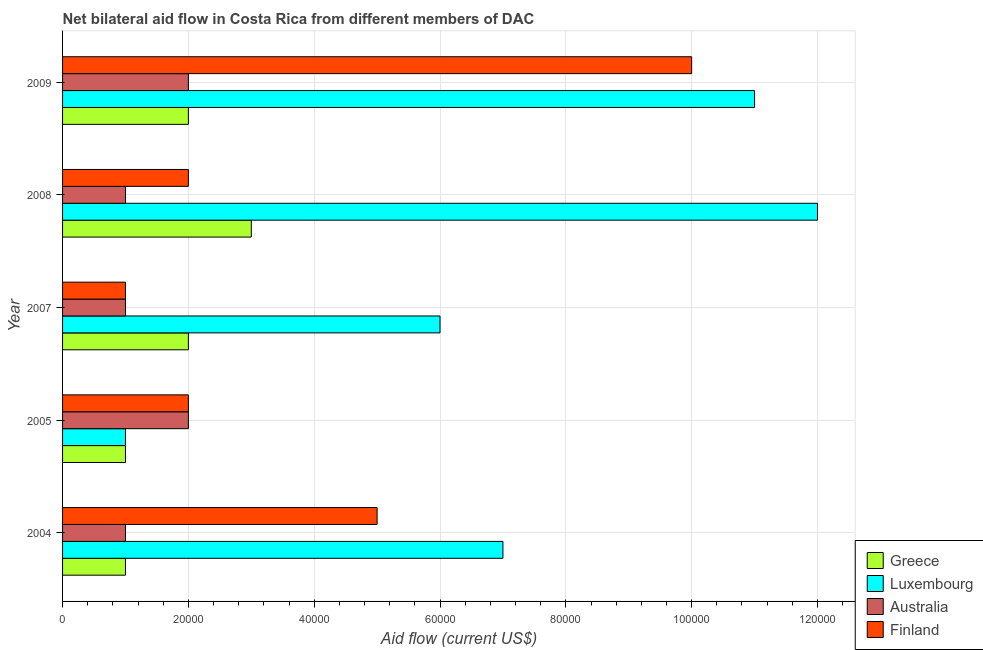How many groups of bars are there?
Your answer should be compact. 5. Are the number of bars per tick equal to the number of legend labels?
Offer a very short reply. Yes. Are the number of bars on each tick of the Y-axis equal?
Provide a short and direct response. Yes. How many bars are there on the 5th tick from the top?
Make the answer very short. 4. What is the label of the 4th group of bars from the top?
Keep it short and to the point. 2005. In how many cases, is the number of bars for a given year not equal to the number of legend labels?
Ensure brevity in your answer.  0. What is the amount of aid given by luxembourg in 2004?
Your answer should be very brief. 7.00e+04. Across all years, what is the maximum amount of aid given by greece?
Keep it short and to the point. 3.00e+04. Across all years, what is the minimum amount of aid given by australia?
Provide a short and direct response. 10000. In which year was the amount of aid given by australia minimum?
Offer a very short reply. 2004. What is the total amount of aid given by finland in the graph?
Your response must be concise. 2.00e+05. What is the difference between the amount of aid given by australia in 2004 and that in 2005?
Offer a very short reply. -10000. What is the average amount of aid given by luxembourg per year?
Give a very brief answer. 7.40e+04. In the year 2008, what is the difference between the amount of aid given by finland and amount of aid given by luxembourg?
Offer a very short reply. -1.00e+05. Is the difference between the amount of aid given by australia in 2004 and 2008 greater than the difference between the amount of aid given by luxembourg in 2004 and 2008?
Offer a terse response. Yes. What is the difference between the highest and the second highest amount of aid given by australia?
Ensure brevity in your answer.  0. What is the difference between the highest and the lowest amount of aid given by australia?
Make the answer very short. 10000. Is it the case that in every year, the sum of the amount of aid given by australia and amount of aid given by luxembourg is greater than the sum of amount of aid given by greece and amount of aid given by finland?
Provide a short and direct response. No. Is it the case that in every year, the sum of the amount of aid given by greece and amount of aid given by luxembourg is greater than the amount of aid given by australia?
Your response must be concise. No. How many bars are there?
Provide a short and direct response. 20. Are all the bars in the graph horizontal?
Your answer should be compact. Yes. How many years are there in the graph?
Ensure brevity in your answer.  5. What is the difference between two consecutive major ticks on the X-axis?
Make the answer very short. 2.00e+04. Where does the legend appear in the graph?
Offer a terse response. Bottom right. How are the legend labels stacked?
Ensure brevity in your answer.  Vertical. What is the title of the graph?
Provide a succinct answer. Net bilateral aid flow in Costa Rica from different members of DAC. Does "Social Insurance" appear as one of the legend labels in the graph?
Provide a short and direct response. No. What is the label or title of the X-axis?
Your answer should be compact. Aid flow (current US$). What is the label or title of the Y-axis?
Your answer should be very brief. Year. What is the Aid flow (current US$) of Luxembourg in 2004?
Your answer should be compact. 7.00e+04. What is the Aid flow (current US$) of Australia in 2004?
Offer a terse response. 10000. What is the Aid flow (current US$) of Luxembourg in 2007?
Offer a terse response. 6.00e+04. What is the Aid flow (current US$) of Australia in 2007?
Give a very brief answer. 10000. What is the Aid flow (current US$) in Greece in 2008?
Keep it short and to the point. 3.00e+04. What is the Aid flow (current US$) in Finland in 2008?
Give a very brief answer. 2.00e+04. What is the Aid flow (current US$) in Greece in 2009?
Your answer should be very brief. 2.00e+04. Across all years, what is the maximum Aid flow (current US$) in Greece?
Your answer should be compact. 3.00e+04. Across all years, what is the maximum Aid flow (current US$) of Finland?
Keep it short and to the point. 1.00e+05. Across all years, what is the minimum Aid flow (current US$) of Greece?
Keep it short and to the point. 10000. Across all years, what is the minimum Aid flow (current US$) in Luxembourg?
Make the answer very short. 10000. Across all years, what is the minimum Aid flow (current US$) in Australia?
Provide a short and direct response. 10000. Across all years, what is the minimum Aid flow (current US$) of Finland?
Provide a succinct answer. 10000. What is the total Aid flow (current US$) of Greece in the graph?
Provide a short and direct response. 9.00e+04. What is the total Aid flow (current US$) of Finland in the graph?
Keep it short and to the point. 2.00e+05. What is the difference between the Aid flow (current US$) in Greece in 2004 and that in 2005?
Offer a very short reply. 0. What is the difference between the Aid flow (current US$) of Australia in 2004 and that in 2005?
Keep it short and to the point. -10000. What is the difference between the Aid flow (current US$) in Luxembourg in 2004 and that in 2007?
Your answer should be compact. 10000. What is the difference between the Aid flow (current US$) of Finland in 2004 and that in 2007?
Provide a succinct answer. 4.00e+04. What is the difference between the Aid flow (current US$) of Luxembourg in 2004 and that in 2008?
Your answer should be very brief. -5.00e+04. What is the difference between the Aid flow (current US$) of Australia in 2004 and that in 2008?
Provide a short and direct response. 0. What is the difference between the Aid flow (current US$) in Greece in 2004 and that in 2009?
Ensure brevity in your answer.  -10000. What is the difference between the Aid flow (current US$) in Finland in 2004 and that in 2009?
Offer a terse response. -5.00e+04. What is the difference between the Aid flow (current US$) of Luxembourg in 2005 and that in 2007?
Your response must be concise. -5.00e+04. What is the difference between the Aid flow (current US$) of Finland in 2005 and that in 2008?
Your answer should be compact. 0. What is the difference between the Aid flow (current US$) of Greece in 2005 and that in 2009?
Your answer should be compact. -10000. What is the difference between the Aid flow (current US$) in Luxembourg in 2005 and that in 2009?
Offer a very short reply. -1.00e+05. What is the difference between the Aid flow (current US$) in Finland in 2007 and that in 2008?
Your answer should be very brief. -10000. What is the difference between the Aid flow (current US$) of Greece in 2007 and that in 2009?
Your answer should be very brief. 0. What is the difference between the Aid flow (current US$) in Luxembourg in 2007 and that in 2009?
Make the answer very short. -5.00e+04. What is the difference between the Aid flow (current US$) in Australia in 2007 and that in 2009?
Keep it short and to the point. -10000. What is the difference between the Aid flow (current US$) in Greece in 2008 and that in 2009?
Keep it short and to the point. 10000. What is the difference between the Aid flow (current US$) of Australia in 2008 and that in 2009?
Your response must be concise. -10000. What is the difference between the Aid flow (current US$) in Australia in 2004 and the Aid flow (current US$) in Finland in 2005?
Offer a terse response. -10000. What is the difference between the Aid flow (current US$) of Greece in 2004 and the Aid flow (current US$) of Luxembourg in 2007?
Ensure brevity in your answer.  -5.00e+04. What is the difference between the Aid flow (current US$) in Greece in 2004 and the Aid flow (current US$) in Australia in 2007?
Your answer should be very brief. 0. What is the difference between the Aid flow (current US$) in Luxembourg in 2004 and the Aid flow (current US$) in Australia in 2007?
Your response must be concise. 6.00e+04. What is the difference between the Aid flow (current US$) of Luxembourg in 2004 and the Aid flow (current US$) of Finland in 2007?
Offer a terse response. 6.00e+04. What is the difference between the Aid flow (current US$) in Australia in 2004 and the Aid flow (current US$) in Finland in 2007?
Your response must be concise. 0. What is the difference between the Aid flow (current US$) of Greece in 2004 and the Aid flow (current US$) of Luxembourg in 2008?
Your answer should be very brief. -1.10e+05. What is the difference between the Aid flow (current US$) in Greece in 2004 and the Aid flow (current US$) in Australia in 2008?
Make the answer very short. 0. What is the difference between the Aid flow (current US$) in Greece in 2004 and the Aid flow (current US$) in Finland in 2008?
Make the answer very short. -10000. What is the difference between the Aid flow (current US$) in Luxembourg in 2004 and the Aid flow (current US$) in Finland in 2008?
Offer a very short reply. 5.00e+04. What is the difference between the Aid flow (current US$) in Greece in 2004 and the Aid flow (current US$) in Finland in 2009?
Your response must be concise. -9.00e+04. What is the difference between the Aid flow (current US$) of Luxembourg in 2004 and the Aid flow (current US$) of Australia in 2009?
Your answer should be very brief. 5.00e+04. What is the difference between the Aid flow (current US$) in Australia in 2004 and the Aid flow (current US$) in Finland in 2009?
Keep it short and to the point. -9.00e+04. What is the difference between the Aid flow (current US$) of Greece in 2005 and the Aid flow (current US$) of Australia in 2007?
Your answer should be compact. 0. What is the difference between the Aid flow (current US$) in Greece in 2005 and the Aid flow (current US$) in Finland in 2007?
Ensure brevity in your answer.  0. What is the difference between the Aid flow (current US$) of Greece in 2005 and the Aid flow (current US$) of Australia in 2008?
Your answer should be very brief. 0. What is the difference between the Aid flow (current US$) in Australia in 2005 and the Aid flow (current US$) in Finland in 2008?
Make the answer very short. 0. What is the difference between the Aid flow (current US$) in Greece in 2005 and the Aid flow (current US$) in Luxembourg in 2009?
Your response must be concise. -1.00e+05. What is the difference between the Aid flow (current US$) in Greece in 2005 and the Aid flow (current US$) in Australia in 2009?
Your answer should be compact. -10000. What is the difference between the Aid flow (current US$) of Greece in 2005 and the Aid flow (current US$) of Finland in 2009?
Keep it short and to the point. -9.00e+04. What is the difference between the Aid flow (current US$) in Australia in 2005 and the Aid flow (current US$) in Finland in 2009?
Provide a succinct answer. -8.00e+04. What is the difference between the Aid flow (current US$) of Greece in 2007 and the Aid flow (current US$) of Luxembourg in 2008?
Make the answer very short. -1.00e+05. What is the difference between the Aid flow (current US$) of Luxembourg in 2007 and the Aid flow (current US$) of Finland in 2008?
Offer a terse response. 4.00e+04. What is the difference between the Aid flow (current US$) in Greece in 2007 and the Aid flow (current US$) in Australia in 2009?
Offer a very short reply. 0. What is the difference between the Aid flow (current US$) of Greece in 2007 and the Aid flow (current US$) of Finland in 2009?
Keep it short and to the point. -8.00e+04. What is the difference between the Aid flow (current US$) of Australia in 2007 and the Aid flow (current US$) of Finland in 2009?
Your answer should be compact. -9.00e+04. What is the difference between the Aid flow (current US$) of Greece in 2008 and the Aid flow (current US$) of Australia in 2009?
Your response must be concise. 10000. What is the difference between the Aid flow (current US$) of Luxembourg in 2008 and the Aid flow (current US$) of Australia in 2009?
Give a very brief answer. 1.00e+05. What is the difference between the Aid flow (current US$) of Australia in 2008 and the Aid flow (current US$) of Finland in 2009?
Provide a short and direct response. -9.00e+04. What is the average Aid flow (current US$) of Greece per year?
Keep it short and to the point. 1.80e+04. What is the average Aid flow (current US$) of Luxembourg per year?
Your response must be concise. 7.40e+04. What is the average Aid flow (current US$) in Australia per year?
Your answer should be compact. 1.40e+04. In the year 2004, what is the difference between the Aid flow (current US$) in Greece and Aid flow (current US$) in Luxembourg?
Offer a terse response. -6.00e+04. In the year 2004, what is the difference between the Aid flow (current US$) in Greece and Aid flow (current US$) in Finland?
Keep it short and to the point. -4.00e+04. In the year 2004, what is the difference between the Aid flow (current US$) in Luxembourg and Aid flow (current US$) in Australia?
Give a very brief answer. 6.00e+04. In the year 2004, what is the difference between the Aid flow (current US$) of Luxembourg and Aid flow (current US$) of Finland?
Offer a very short reply. 2.00e+04. In the year 2005, what is the difference between the Aid flow (current US$) of Greece and Aid flow (current US$) of Australia?
Provide a short and direct response. -10000. In the year 2005, what is the difference between the Aid flow (current US$) of Luxembourg and Aid flow (current US$) of Finland?
Provide a succinct answer. -10000. In the year 2005, what is the difference between the Aid flow (current US$) of Australia and Aid flow (current US$) of Finland?
Give a very brief answer. 0. In the year 2007, what is the difference between the Aid flow (current US$) in Greece and Aid flow (current US$) in Luxembourg?
Make the answer very short. -4.00e+04. In the year 2007, what is the difference between the Aid flow (current US$) in Greece and Aid flow (current US$) in Finland?
Offer a terse response. 10000. In the year 2007, what is the difference between the Aid flow (current US$) of Luxembourg and Aid flow (current US$) of Australia?
Offer a very short reply. 5.00e+04. In the year 2007, what is the difference between the Aid flow (current US$) in Luxembourg and Aid flow (current US$) in Finland?
Offer a terse response. 5.00e+04. In the year 2008, what is the difference between the Aid flow (current US$) in Luxembourg and Aid flow (current US$) in Australia?
Keep it short and to the point. 1.10e+05. In the year 2008, what is the difference between the Aid flow (current US$) in Luxembourg and Aid flow (current US$) in Finland?
Make the answer very short. 1.00e+05. In the year 2009, what is the difference between the Aid flow (current US$) in Greece and Aid flow (current US$) in Luxembourg?
Give a very brief answer. -9.00e+04. In the year 2009, what is the difference between the Aid flow (current US$) in Greece and Aid flow (current US$) in Finland?
Provide a short and direct response. -8.00e+04. In the year 2009, what is the difference between the Aid flow (current US$) in Luxembourg and Aid flow (current US$) in Finland?
Offer a terse response. 10000. In the year 2009, what is the difference between the Aid flow (current US$) of Australia and Aid flow (current US$) of Finland?
Provide a succinct answer. -8.00e+04. What is the ratio of the Aid flow (current US$) of Greece in 2004 to that in 2005?
Make the answer very short. 1. What is the ratio of the Aid flow (current US$) of Luxembourg in 2004 to that in 2005?
Provide a short and direct response. 7. What is the ratio of the Aid flow (current US$) of Australia in 2004 to that in 2005?
Provide a succinct answer. 0.5. What is the ratio of the Aid flow (current US$) of Finland in 2004 to that in 2005?
Ensure brevity in your answer.  2.5. What is the ratio of the Aid flow (current US$) in Greece in 2004 to that in 2007?
Your answer should be compact. 0.5. What is the ratio of the Aid flow (current US$) in Luxembourg in 2004 to that in 2007?
Offer a very short reply. 1.17. What is the ratio of the Aid flow (current US$) in Finland in 2004 to that in 2007?
Provide a short and direct response. 5. What is the ratio of the Aid flow (current US$) of Luxembourg in 2004 to that in 2008?
Keep it short and to the point. 0.58. What is the ratio of the Aid flow (current US$) in Australia in 2004 to that in 2008?
Your response must be concise. 1. What is the ratio of the Aid flow (current US$) of Finland in 2004 to that in 2008?
Keep it short and to the point. 2.5. What is the ratio of the Aid flow (current US$) of Luxembourg in 2004 to that in 2009?
Give a very brief answer. 0.64. What is the ratio of the Aid flow (current US$) in Greece in 2005 to that in 2007?
Make the answer very short. 0.5. What is the ratio of the Aid flow (current US$) in Greece in 2005 to that in 2008?
Provide a short and direct response. 0.33. What is the ratio of the Aid flow (current US$) in Luxembourg in 2005 to that in 2008?
Offer a terse response. 0.08. What is the ratio of the Aid flow (current US$) in Australia in 2005 to that in 2008?
Your answer should be very brief. 2. What is the ratio of the Aid flow (current US$) of Finland in 2005 to that in 2008?
Make the answer very short. 1. What is the ratio of the Aid flow (current US$) in Greece in 2005 to that in 2009?
Provide a short and direct response. 0.5. What is the ratio of the Aid flow (current US$) of Luxembourg in 2005 to that in 2009?
Provide a short and direct response. 0.09. What is the ratio of the Aid flow (current US$) in Australia in 2005 to that in 2009?
Ensure brevity in your answer.  1. What is the ratio of the Aid flow (current US$) of Greece in 2007 to that in 2008?
Offer a very short reply. 0.67. What is the ratio of the Aid flow (current US$) of Luxembourg in 2007 to that in 2008?
Keep it short and to the point. 0.5. What is the ratio of the Aid flow (current US$) of Australia in 2007 to that in 2008?
Make the answer very short. 1. What is the ratio of the Aid flow (current US$) of Finland in 2007 to that in 2008?
Your answer should be compact. 0.5. What is the ratio of the Aid flow (current US$) in Luxembourg in 2007 to that in 2009?
Your response must be concise. 0.55. What is the ratio of the Aid flow (current US$) of Australia in 2007 to that in 2009?
Your response must be concise. 0.5. What is the ratio of the Aid flow (current US$) of Greece in 2008 to that in 2009?
Keep it short and to the point. 1.5. What is the ratio of the Aid flow (current US$) in Luxembourg in 2008 to that in 2009?
Provide a short and direct response. 1.09. What is the ratio of the Aid flow (current US$) in Australia in 2008 to that in 2009?
Your answer should be very brief. 0.5. What is the ratio of the Aid flow (current US$) of Finland in 2008 to that in 2009?
Make the answer very short. 0.2. What is the difference between the highest and the second highest Aid flow (current US$) of Greece?
Your answer should be compact. 10000. What is the difference between the highest and the second highest Aid flow (current US$) in Luxembourg?
Provide a succinct answer. 10000. What is the difference between the highest and the second highest Aid flow (current US$) in Australia?
Keep it short and to the point. 0. What is the difference between the highest and the second highest Aid flow (current US$) of Finland?
Your answer should be very brief. 5.00e+04. What is the difference between the highest and the lowest Aid flow (current US$) of Australia?
Make the answer very short. 10000. What is the difference between the highest and the lowest Aid flow (current US$) of Finland?
Provide a short and direct response. 9.00e+04. 